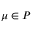<formula> <loc_0><loc_0><loc_500><loc_500>\mu \in \mathcal { P }</formula> 